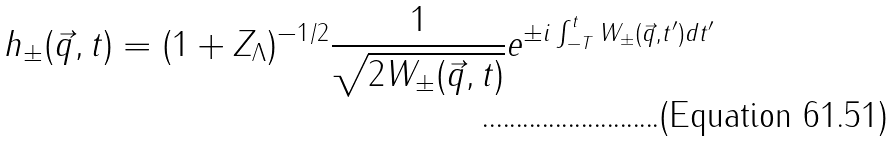Convert formula to latex. <formula><loc_0><loc_0><loc_500><loc_500>h _ { \pm } ( \vec { q } , t ) = ( 1 + Z _ { \Lambda } ) ^ { - 1 / 2 } \frac { 1 } { \sqrt { 2 W _ { \pm } ( \vec { q } , t ) } } e ^ { \pm i \int _ { - T } ^ { t } W _ { \pm } ( \vec { q } , t ^ { \prime } ) d t ^ { \prime } }</formula> 